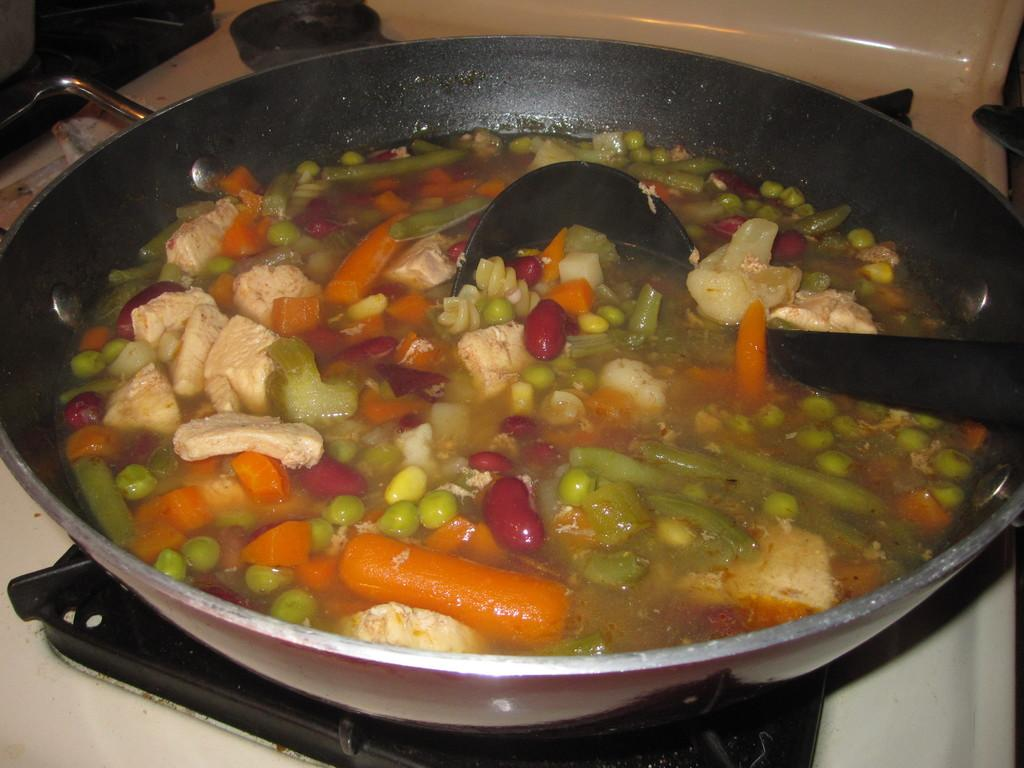What is in the pan that is visible in the image? There is a pan containing vegetables in the image. What is the liquid in the pan? There is water in the pan. Where is the spoon located in the image? The spoon is placed on the gas stove. What is the pan placed on in the image? The pan is placed on the gas stove. What type of plantation can be seen in the image? There is no plantation present in the image; it features a pan with vegetables on a gas stove. Which direction is the group of people facing in the image? There is no group of people present in the image. 